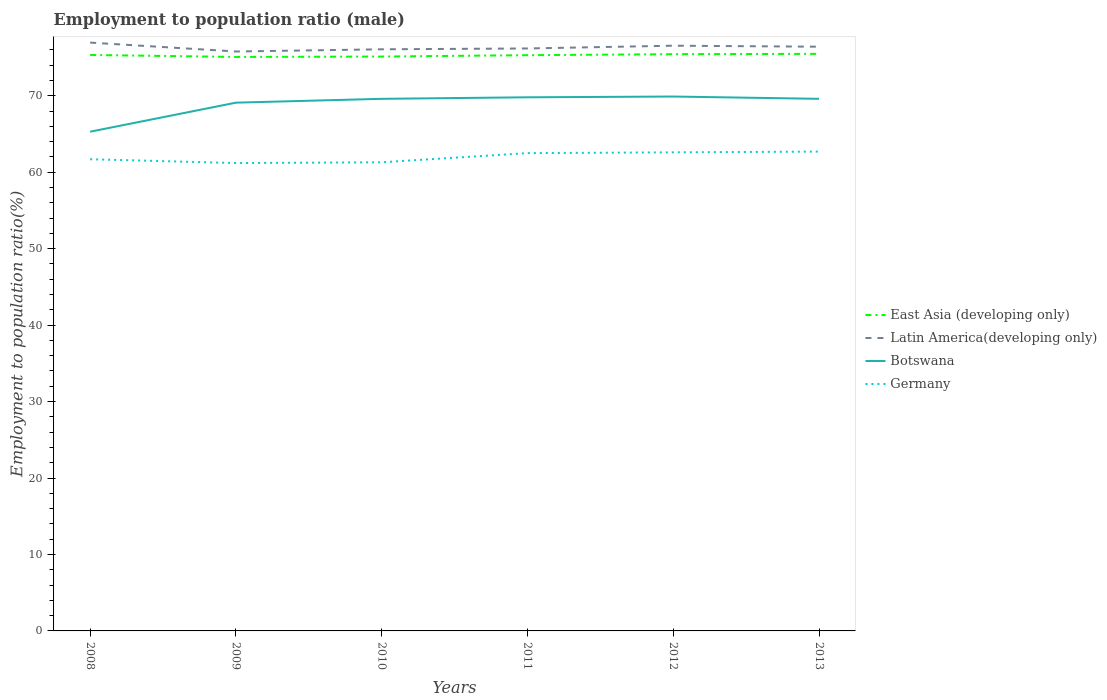How many different coloured lines are there?
Ensure brevity in your answer.  4. Is the number of lines equal to the number of legend labels?
Your answer should be very brief. Yes. Across all years, what is the maximum employment to population ratio in Germany?
Ensure brevity in your answer.  61.2. What is the total employment to population ratio in Botswana in the graph?
Ensure brevity in your answer.  0. What is the difference between the highest and the second highest employment to population ratio in Botswana?
Your answer should be compact. 4.6. What is the difference between the highest and the lowest employment to population ratio in East Asia (developing only)?
Your response must be concise. 4. How many years are there in the graph?
Your answer should be compact. 6. What is the difference between two consecutive major ticks on the Y-axis?
Your response must be concise. 10. Does the graph contain any zero values?
Offer a very short reply. No. Does the graph contain grids?
Your response must be concise. No. Where does the legend appear in the graph?
Make the answer very short. Center right. How are the legend labels stacked?
Provide a succinct answer. Vertical. What is the title of the graph?
Keep it short and to the point. Employment to population ratio (male). What is the label or title of the X-axis?
Your answer should be very brief. Years. What is the label or title of the Y-axis?
Ensure brevity in your answer.  Employment to population ratio(%). What is the Employment to population ratio(%) of East Asia (developing only) in 2008?
Give a very brief answer. 75.34. What is the Employment to population ratio(%) of Latin America(developing only) in 2008?
Your answer should be very brief. 76.96. What is the Employment to population ratio(%) in Botswana in 2008?
Give a very brief answer. 65.3. What is the Employment to population ratio(%) in Germany in 2008?
Ensure brevity in your answer.  61.7. What is the Employment to population ratio(%) of East Asia (developing only) in 2009?
Keep it short and to the point. 75.08. What is the Employment to population ratio(%) of Latin America(developing only) in 2009?
Provide a short and direct response. 75.79. What is the Employment to population ratio(%) of Botswana in 2009?
Provide a short and direct response. 69.1. What is the Employment to population ratio(%) in Germany in 2009?
Offer a terse response. 61.2. What is the Employment to population ratio(%) in East Asia (developing only) in 2010?
Your answer should be compact. 75.13. What is the Employment to population ratio(%) of Latin America(developing only) in 2010?
Your response must be concise. 76.08. What is the Employment to population ratio(%) in Botswana in 2010?
Provide a succinct answer. 69.6. What is the Employment to population ratio(%) in Germany in 2010?
Your response must be concise. 61.3. What is the Employment to population ratio(%) of East Asia (developing only) in 2011?
Offer a very short reply. 75.31. What is the Employment to population ratio(%) of Latin America(developing only) in 2011?
Your answer should be very brief. 76.19. What is the Employment to population ratio(%) in Botswana in 2011?
Provide a succinct answer. 69.8. What is the Employment to population ratio(%) in Germany in 2011?
Ensure brevity in your answer.  62.5. What is the Employment to population ratio(%) of East Asia (developing only) in 2012?
Provide a short and direct response. 75.44. What is the Employment to population ratio(%) of Latin America(developing only) in 2012?
Your answer should be very brief. 76.55. What is the Employment to population ratio(%) of Botswana in 2012?
Your answer should be compact. 69.9. What is the Employment to population ratio(%) of Germany in 2012?
Make the answer very short. 62.6. What is the Employment to population ratio(%) in East Asia (developing only) in 2013?
Your answer should be very brief. 75.48. What is the Employment to population ratio(%) in Latin America(developing only) in 2013?
Ensure brevity in your answer.  76.42. What is the Employment to population ratio(%) in Botswana in 2013?
Offer a terse response. 69.6. What is the Employment to population ratio(%) of Germany in 2013?
Make the answer very short. 62.7. Across all years, what is the maximum Employment to population ratio(%) in East Asia (developing only)?
Provide a short and direct response. 75.48. Across all years, what is the maximum Employment to population ratio(%) in Latin America(developing only)?
Provide a succinct answer. 76.96. Across all years, what is the maximum Employment to population ratio(%) of Botswana?
Offer a terse response. 69.9. Across all years, what is the maximum Employment to population ratio(%) of Germany?
Your answer should be compact. 62.7. Across all years, what is the minimum Employment to population ratio(%) in East Asia (developing only)?
Your answer should be compact. 75.08. Across all years, what is the minimum Employment to population ratio(%) in Latin America(developing only)?
Offer a very short reply. 75.79. Across all years, what is the minimum Employment to population ratio(%) in Botswana?
Make the answer very short. 65.3. Across all years, what is the minimum Employment to population ratio(%) in Germany?
Your response must be concise. 61.2. What is the total Employment to population ratio(%) in East Asia (developing only) in the graph?
Ensure brevity in your answer.  451.79. What is the total Employment to population ratio(%) in Latin America(developing only) in the graph?
Offer a very short reply. 457.98. What is the total Employment to population ratio(%) in Botswana in the graph?
Your answer should be very brief. 413.3. What is the total Employment to population ratio(%) of Germany in the graph?
Make the answer very short. 372. What is the difference between the Employment to population ratio(%) in East Asia (developing only) in 2008 and that in 2009?
Offer a very short reply. 0.26. What is the difference between the Employment to population ratio(%) of Latin America(developing only) in 2008 and that in 2009?
Your answer should be very brief. 1.16. What is the difference between the Employment to population ratio(%) of Germany in 2008 and that in 2009?
Ensure brevity in your answer.  0.5. What is the difference between the Employment to population ratio(%) in East Asia (developing only) in 2008 and that in 2010?
Give a very brief answer. 0.21. What is the difference between the Employment to population ratio(%) of Latin America(developing only) in 2008 and that in 2010?
Offer a terse response. 0.88. What is the difference between the Employment to population ratio(%) in Botswana in 2008 and that in 2010?
Keep it short and to the point. -4.3. What is the difference between the Employment to population ratio(%) of Germany in 2008 and that in 2010?
Your answer should be very brief. 0.4. What is the difference between the Employment to population ratio(%) in East Asia (developing only) in 2008 and that in 2011?
Give a very brief answer. 0.03. What is the difference between the Employment to population ratio(%) in Latin America(developing only) in 2008 and that in 2011?
Offer a terse response. 0.77. What is the difference between the Employment to population ratio(%) of Germany in 2008 and that in 2011?
Your response must be concise. -0.8. What is the difference between the Employment to population ratio(%) in East Asia (developing only) in 2008 and that in 2012?
Your response must be concise. -0.1. What is the difference between the Employment to population ratio(%) in Latin America(developing only) in 2008 and that in 2012?
Give a very brief answer. 0.41. What is the difference between the Employment to population ratio(%) of Botswana in 2008 and that in 2012?
Offer a terse response. -4.6. What is the difference between the Employment to population ratio(%) in Germany in 2008 and that in 2012?
Your response must be concise. -0.9. What is the difference between the Employment to population ratio(%) of East Asia (developing only) in 2008 and that in 2013?
Offer a very short reply. -0.14. What is the difference between the Employment to population ratio(%) in Latin America(developing only) in 2008 and that in 2013?
Make the answer very short. 0.54. What is the difference between the Employment to population ratio(%) of Botswana in 2008 and that in 2013?
Ensure brevity in your answer.  -4.3. What is the difference between the Employment to population ratio(%) in East Asia (developing only) in 2009 and that in 2010?
Provide a succinct answer. -0.05. What is the difference between the Employment to population ratio(%) in Latin America(developing only) in 2009 and that in 2010?
Keep it short and to the point. -0.29. What is the difference between the Employment to population ratio(%) in Germany in 2009 and that in 2010?
Keep it short and to the point. -0.1. What is the difference between the Employment to population ratio(%) of East Asia (developing only) in 2009 and that in 2011?
Your answer should be very brief. -0.23. What is the difference between the Employment to population ratio(%) in Latin America(developing only) in 2009 and that in 2011?
Offer a terse response. -0.4. What is the difference between the Employment to population ratio(%) in Germany in 2009 and that in 2011?
Ensure brevity in your answer.  -1.3. What is the difference between the Employment to population ratio(%) of East Asia (developing only) in 2009 and that in 2012?
Make the answer very short. -0.36. What is the difference between the Employment to population ratio(%) in Latin America(developing only) in 2009 and that in 2012?
Make the answer very short. -0.76. What is the difference between the Employment to population ratio(%) of Botswana in 2009 and that in 2012?
Give a very brief answer. -0.8. What is the difference between the Employment to population ratio(%) of East Asia (developing only) in 2009 and that in 2013?
Your response must be concise. -0.41. What is the difference between the Employment to population ratio(%) in Latin America(developing only) in 2009 and that in 2013?
Keep it short and to the point. -0.63. What is the difference between the Employment to population ratio(%) of Botswana in 2009 and that in 2013?
Provide a succinct answer. -0.5. What is the difference between the Employment to population ratio(%) in East Asia (developing only) in 2010 and that in 2011?
Offer a very short reply. -0.18. What is the difference between the Employment to population ratio(%) of Latin America(developing only) in 2010 and that in 2011?
Offer a terse response. -0.11. What is the difference between the Employment to population ratio(%) of Botswana in 2010 and that in 2011?
Give a very brief answer. -0.2. What is the difference between the Employment to population ratio(%) in East Asia (developing only) in 2010 and that in 2012?
Ensure brevity in your answer.  -0.31. What is the difference between the Employment to population ratio(%) in Latin America(developing only) in 2010 and that in 2012?
Offer a terse response. -0.47. What is the difference between the Employment to population ratio(%) in Botswana in 2010 and that in 2012?
Your answer should be very brief. -0.3. What is the difference between the Employment to population ratio(%) in East Asia (developing only) in 2010 and that in 2013?
Offer a terse response. -0.35. What is the difference between the Employment to population ratio(%) in Latin America(developing only) in 2010 and that in 2013?
Provide a short and direct response. -0.34. What is the difference between the Employment to population ratio(%) in Botswana in 2010 and that in 2013?
Your answer should be compact. 0. What is the difference between the Employment to population ratio(%) in Germany in 2010 and that in 2013?
Ensure brevity in your answer.  -1.4. What is the difference between the Employment to population ratio(%) in East Asia (developing only) in 2011 and that in 2012?
Your answer should be compact. -0.13. What is the difference between the Employment to population ratio(%) of Latin America(developing only) in 2011 and that in 2012?
Offer a very short reply. -0.36. What is the difference between the Employment to population ratio(%) in East Asia (developing only) in 2011 and that in 2013?
Keep it short and to the point. -0.17. What is the difference between the Employment to population ratio(%) in Latin America(developing only) in 2011 and that in 2013?
Give a very brief answer. -0.23. What is the difference between the Employment to population ratio(%) of Botswana in 2011 and that in 2013?
Your answer should be very brief. 0.2. What is the difference between the Employment to population ratio(%) in Germany in 2011 and that in 2013?
Give a very brief answer. -0.2. What is the difference between the Employment to population ratio(%) of East Asia (developing only) in 2012 and that in 2013?
Your answer should be compact. -0.04. What is the difference between the Employment to population ratio(%) in Latin America(developing only) in 2012 and that in 2013?
Offer a terse response. 0.13. What is the difference between the Employment to population ratio(%) in Botswana in 2012 and that in 2013?
Provide a short and direct response. 0.3. What is the difference between the Employment to population ratio(%) of Germany in 2012 and that in 2013?
Provide a succinct answer. -0.1. What is the difference between the Employment to population ratio(%) of East Asia (developing only) in 2008 and the Employment to population ratio(%) of Latin America(developing only) in 2009?
Make the answer very short. -0.45. What is the difference between the Employment to population ratio(%) of East Asia (developing only) in 2008 and the Employment to population ratio(%) of Botswana in 2009?
Make the answer very short. 6.24. What is the difference between the Employment to population ratio(%) of East Asia (developing only) in 2008 and the Employment to population ratio(%) of Germany in 2009?
Your response must be concise. 14.14. What is the difference between the Employment to population ratio(%) in Latin America(developing only) in 2008 and the Employment to population ratio(%) in Botswana in 2009?
Provide a short and direct response. 7.86. What is the difference between the Employment to population ratio(%) in Latin America(developing only) in 2008 and the Employment to population ratio(%) in Germany in 2009?
Make the answer very short. 15.76. What is the difference between the Employment to population ratio(%) of Botswana in 2008 and the Employment to population ratio(%) of Germany in 2009?
Your answer should be very brief. 4.1. What is the difference between the Employment to population ratio(%) of East Asia (developing only) in 2008 and the Employment to population ratio(%) of Latin America(developing only) in 2010?
Provide a succinct answer. -0.74. What is the difference between the Employment to population ratio(%) of East Asia (developing only) in 2008 and the Employment to population ratio(%) of Botswana in 2010?
Your answer should be compact. 5.74. What is the difference between the Employment to population ratio(%) of East Asia (developing only) in 2008 and the Employment to population ratio(%) of Germany in 2010?
Your response must be concise. 14.04. What is the difference between the Employment to population ratio(%) of Latin America(developing only) in 2008 and the Employment to population ratio(%) of Botswana in 2010?
Your answer should be compact. 7.36. What is the difference between the Employment to population ratio(%) in Latin America(developing only) in 2008 and the Employment to population ratio(%) in Germany in 2010?
Provide a succinct answer. 15.66. What is the difference between the Employment to population ratio(%) in East Asia (developing only) in 2008 and the Employment to population ratio(%) in Latin America(developing only) in 2011?
Offer a very short reply. -0.85. What is the difference between the Employment to population ratio(%) of East Asia (developing only) in 2008 and the Employment to population ratio(%) of Botswana in 2011?
Make the answer very short. 5.54. What is the difference between the Employment to population ratio(%) of East Asia (developing only) in 2008 and the Employment to population ratio(%) of Germany in 2011?
Offer a very short reply. 12.84. What is the difference between the Employment to population ratio(%) in Latin America(developing only) in 2008 and the Employment to population ratio(%) in Botswana in 2011?
Your answer should be very brief. 7.16. What is the difference between the Employment to population ratio(%) in Latin America(developing only) in 2008 and the Employment to population ratio(%) in Germany in 2011?
Your response must be concise. 14.46. What is the difference between the Employment to population ratio(%) of Botswana in 2008 and the Employment to population ratio(%) of Germany in 2011?
Provide a succinct answer. 2.8. What is the difference between the Employment to population ratio(%) in East Asia (developing only) in 2008 and the Employment to population ratio(%) in Latin America(developing only) in 2012?
Keep it short and to the point. -1.21. What is the difference between the Employment to population ratio(%) in East Asia (developing only) in 2008 and the Employment to population ratio(%) in Botswana in 2012?
Provide a short and direct response. 5.44. What is the difference between the Employment to population ratio(%) of East Asia (developing only) in 2008 and the Employment to population ratio(%) of Germany in 2012?
Your response must be concise. 12.74. What is the difference between the Employment to population ratio(%) in Latin America(developing only) in 2008 and the Employment to population ratio(%) in Botswana in 2012?
Offer a terse response. 7.06. What is the difference between the Employment to population ratio(%) in Latin America(developing only) in 2008 and the Employment to population ratio(%) in Germany in 2012?
Provide a short and direct response. 14.36. What is the difference between the Employment to population ratio(%) of Botswana in 2008 and the Employment to population ratio(%) of Germany in 2012?
Your answer should be very brief. 2.7. What is the difference between the Employment to population ratio(%) of East Asia (developing only) in 2008 and the Employment to population ratio(%) of Latin America(developing only) in 2013?
Keep it short and to the point. -1.08. What is the difference between the Employment to population ratio(%) of East Asia (developing only) in 2008 and the Employment to population ratio(%) of Botswana in 2013?
Offer a very short reply. 5.74. What is the difference between the Employment to population ratio(%) of East Asia (developing only) in 2008 and the Employment to population ratio(%) of Germany in 2013?
Your answer should be compact. 12.64. What is the difference between the Employment to population ratio(%) in Latin America(developing only) in 2008 and the Employment to population ratio(%) in Botswana in 2013?
Offer a very short reply. 7.36. What is the difference between the Employment to population ratio(%) in Latin America(developing only) in 2008 and the Employment to population ratio(%) in Germany in 2013?
Your answer should be very brief. 14.26. What is the difference between the Employment to population ratio(%) of Botswana in 2008 and the Employment to population ratio(%) of Germany in 2013?
Provide a succinct answer. 2.6. What is the difference between the Employment to population ratio(%) of East Asia (developing only) in 2009 and the Employment to population ratio(%) of Latin America(developing only) in 2010?
Ensure brevity in your answer.  -1. What is the difference between the Employment to population ratio(%) in East Asia (developing only) in 2009 and the Employment to population ratio(%) in Botswana in 2010?
Keep it short and to the point. 5.48. What is the difference between the Employment to population ratio(%) in East Asia (developing only) in 2009 and the Employment to population ratio(%) in Germany in 2010?
Your answer should be very brief. 13.78. What is the difference between the Employment to population ratio(%) of Latin America(developing only) in 2009 and the Employment to population ratio(%) of Botswana in 2010?
Keep it short and to the point. 6.19. What is the difference between the Employment to population ratio(%) in Latin America(developing only) in 2009 and the Employment to population ratio(%) in Germany in 2010?
Provide a short and direct response. 14.49. What is the difference between the Employment to population ratio(%) of East Asia (developing only) in 2009 and the Employment to population ratio(%) of Latin America(developing only) in 2011?
Ensure brevity in your answer.  -1.11. What is the difference between the Employment to population ratio(%) in East Asia (developing only) in 2009 and the Employment to population ratio(%) in Botswana in 2011?
Provide a short and direct response. 5.28. What is the difference between the Employment to population ratio(%) of East Asia (developing only) in 2009 and the Employment to population ratio(%) of Germany in 2011?
Your answer should be very brief. 12.58. What is the difference between the Employment to population ratio(%) of Latin America(developing only) in 2009 and the Employment to population ratio(%) of Botswana in 2011?
Make the answer very short. 5.99. What is the difference between the Employment to population ratio(%) of Latin America(developing only) in 2009 and the Employment to population ratio(%) of Germany in 2011?
Offer a very short reply. 13.29. What is the difference between the Employment to population ratio(%) of Botswana in 2009 and the Employment to population ratio(%) of Germany in 2011?
Ensure brevity in your answer.  6.6. What is the difference between the Employment to population ratio(%) in East Asia (developing only) in 2009 and the Employment to population ratio(%) in Latin America(developing only) in 2012?
Provide a succinct answer. -1.47. What is the difference between the Employment to population ratio(%) in East Asia (developing only) in 2009 and the Employment to population ratio(%) in Botswana in 2012?
Offer a terse response. 5.18. What is the difference between the Employment to population ratio(%) of East Asia (developing only) in 2009 and the Employment to population ratio(%) of Germany in 2012?
Keep it short and to the point. 12.48. What is the difference between the Employment to population ratio(%) of Latin America(developing only) in 2009 and the Employment to population ratio(%) of Botswana in 2012?
Make the answer very short. 5.89. What is the difference between the Employment to population ratio(%) of Latin America(developing only) in 2009 and the Employment to population ratio(%) of Germany in 2012?
Make the answer very short. 13.19. What is the difference between the Employment to population ratio(%) of East Asia (developing only) in 2009 and the Employment to population ratio(%) of Latin America(developing only) in 2013?
Provide a short and direct response. -1.34. What is the difference between the Employment to population ratio(%) of East Asia (developing only) in 2009 and the Employment to population ratio(%) of Botswana in 2013?
Ensure brevity in your answer.  5.48. What is the difference between the Employment to population ratio(%) of East Asia (developing only) in 2009 and the Employment to population ratio(%) of Germany in 2013?
Offer a very short reply. 12.38. What is the difference between the Employment to population ratio(%) of Latin America(developing only) in 2009 and the Employment to population ratio(%) of Botswana in 2013?
Offer a very short reply. 6.19. What is the difference between the Employment to population ratio(%) in Latin America(developing only) in 2009 and the Employment to population ratio(%) in Germany in 2013?
Your answer should be very brief. 13.09. What is the difference between the Employment to population ratio(%) in East Asia (developing only) in 2010 and the Employment to population ratio(%) in Latin America(developing only) in 2011?
Ensure brevity in your answer.  -1.06. What is the difference between the Employment to population ratio(%) in East Asia (developing only) in 2010 and the Employment to population ratio(%) in Botswana in 2011?
Your answer should be compact. 5.33. What is the difference between the Employment to population ratio(%) of East Asia (developing only) in 2010 and the Employment to population ratio(%) of Germany in 2011?
Give a very brief answer. 12.63. What is the difference between the Employment to population ratio(%) in Latin America(developing only) in 2010 and the Employment to population ratio(%) in Botswana in 2011?
Ensure brevity in your answer.  6.28. What is the difference between the Employment to population ratio(%) in Latin America(developing only) in 2010 and the Employment to population ratio(%) in Germany in 2011?
Offer a very short reply. 13.58. What is the difference between the Employment to population ratio(%) in East Asia (developing only) in 2010 and the Employment to population ratio(%) in Latin America(developing only) in 2012?
Offer a very short reply. -1.42. What is the difference between the Employment to population ratio(%) of East Asia (developing only) in 2010 and the Employment to population ratio(%) of Botswana in 2012?
Keep it short and to the point. 5.23. What is the difference between the Employment to population ratio(%) in East Asia (developing only) in 2010 and the Employment to population ratio(%) in Germany in 2012?
Your response must be concise. 12.53. What is the difference between the Employment to population ratio(%) of Latin America(developing only) in 2010 and the Employment to population ratio(%) of Botswana in 2012?
Offer a very short reply. 6.18. What is the difference between the Employment to population ratio(%) of Latin America(developing only) in 2010 and the Employment to population ratio(%) of Germany in 2012?
Offer a very short reply. 13.48. What is the difference between the Employment to population ratio(%) of East Asia (developing only) in 2010 and the Employment to population ratio(%) of Latin America(developing only) in 2013?
Your answer should be very brief. -1.29. What is the difference between the Employment to population ratio(%) in East Asia (developing only) in 2010 and the Employment to population ratio(%) in Botswana in 2013?
Provide a short and direct response. 5.53. What is the difference between the Employment to population ratio(%) of East Asia (developing only) in 2010 and the Employment to population ratio(%) of Germany in 2013?
Provide a short and direct response. 12.43. What is the difference between the Employment to population ratio(%) of Latin America(developing only) in 2010 and the Employment to population ratio(%) of Botswana in 2013?
Provide a short and direct response. 6.48. What is the difference between the Employment to population ratio(%) of Latin America(developing only) in 2010 and the Employment to population ratio(%) of Germany in 2013?
Your response must be concise. 13.38. What is the difference between the Employment to population ratio(%) of Botswana in 2010 and the Employment to population ratio(%) of Germany in 2013?
Offer a very short reply. 6.9. What is the difference between the Employment to population ratio(%) of East Asia (developing only) in 2011 and the Employment to population ratio(%) of Latin America(developing only) in 2012?
Your answer should be compact. -1.24. What is the difference between the Employment to population ratio(%) in East Asia (developing only) in 2011 and the Employment to population ratio(%) in Botswana in 2012?
Keep it short and to the point. 5.41. What is the difference between the Employment to population ratio(%) of East Asia (developing only) in 2011 and the Employment to population ratio(%) of Germany in 2012?
Offer a very short reply. 12.71. What is the difference between the Employment to population ratio(%) of Latin America(developing only) in 2011 and the Employment to population ratio(%) of Botswana in 2012?
Keep it short and to the point. 6.29. What is the difference between the Employment to population ratio(%) in Latin America(developing only) in 2011 and the Employment to population ratio(%) in Germany in 2012?
Provide a succinct answer. 13.59. What is the difference between the Employment to population ratio(%) in Botswana in 2011 and the Employment to population ratio(%) in Germany in 2012?
Offer a terse response. 7.2. What is the difference between the Employment to population ratio(%) of East Asia (developing only) in 2011 and the Employment to population ratio(%) of Latin America(developing only) in 2013?
Provide a short and direct response. -1.11. What is the difference between the Employment to population ratio(%) in East Asia (developing only) in 2011 and the Employment to population ratio(%) in Botswana in 2013?
Offer a very short reply. 5.71. What is the difference between the Employment to population ratio(%) in East Asia (developing only) in 2011 and the Employment to population ratio(%) in Germany in 2013?
Make the answer very short. 12.61. What is the difference between the Employment to population ratio(%) in Latin America(developing only) in 2011 and the Employment to population ratio(%) in Botswana in 2013?
Ensure brevity in your answer.  6.59. What is the difference between the Employment to population ratio(%) in Latin America(developing only) in 2011 and the Employment to population ratio(%) in Germany in 2013?
Keep it short and to the point. 13.49. What is the difference between the Employment to population ratio(%) of Botswana in 2011 and the Employment to population ratio(%) of Germany in 2013?
Your answer should be compact. 7.1. What is the difference between the Employment to population ratio(%) in East Asia (developing only) in 2012 and the Employment to population ratio(%) in Latin America(developing only) in 2013?
Make the answer very short. -0.98. What is the difference between the Employment to population ratio(%) in East Asia (developing only) in 2012 and the Employment to population ratio(%) in Botswana in 2013?
Offer a terse response. 5.84. What is the difference between the Employment to population ratio(%) of East Asia (developing only) in 2012 and the Employment to population ratio(%) of Germany in 2013?
Your answer should be compact. 12.74. What is the difference between the Employment to population ratio(%) in Latin America(developing only) in 2012 and the Employment to population ratio(%) in Botswana in 2013?
Offer a terse response. 6.95. What is the difference between the Employment to population ratio(%) in Latin America(developing only) in 2012 and the Employment to population ratio(%) in Germany in 2013?
Ensure brevity in your answer.  13.85. What is the average Employment to population ratio(%) of East Asia (developing only) per year?
Provide a succinct answer. 75.3. What is the average Employment to population ratio(%) of Latin America(developing only) per year?
Your response must be concise. 76.33. What is the average Employment to population ratio(%) of Botswana per year?
Offer a very short reply. 68.88. What is the average Employment to population ratio(%) in Germany per year?
Offer a terse response. 62. In the year 2008, what is the difference between the Employment to population ratio(%) of East Asia (developing only) and Employment to population ratio(%) of Latin America(developing only)?
Offer a very short reply. -1.62. In the year 2008, what is the difference between the Employment to population ratio(%) of East Asia (developing only) and Employment to population ratio(%) of Botswana?
Give a very brief answer. 10.04. In the year 2008, what is the difference between the Employment to population ratio(%) of East Asia (developing only) and Employment to population ratio(%) of Germany?
Offer a terse response. 13.64. In the year 2008, what is the difference between the Employment to population ratio(%) of Latin America(developing only) and Employment to population ratio(%) of Botswana?
Provide a short and direct response. 11.66. In the year 2008, what is the difference between the Employment to population ratio(%) of Latin America(developing only) and Employment to population ratio(%) of Germany?
Your response must be concise. 15.26. In the year 2009, what is the difference between the Employment to population ratio(%) of East Asia (developing only) and Employment to population ratio(%) of Latin America(developing only)?
Give a very brief answer. -0.71. In the year 2009, what is the difference between the Employment to population ratio(%) in East Asia (developing only) and Employment to population ratio(%) in Botswana?
Your response must be concise. 5.98. In the year 2009, what is the difference between the Employment to population ratio(%) in East Asia (developing only) and Employment to population ratio(%) in Germany?
Give a very brief answer. 13.88. In the year 2009, what is the difference between the Employment to population ratio(%) of Latin America(developing only) and Employment to population ratio(%) of Botswana?
Give a very brief answer. 6.69. In the year 2009, what is the difference between the Employment to population ratio(%) in Latin America(developing only) and Employment to population ratio(%) in Germany?
Make the answer very short. 14.59. In the year 2010, what is the difference between the Employment to population ratio(%) of East Asia (developing only) and Employment to population ratio(%) of Latin America(developing only)?
Provide a short and direct response. -0.95. In the year 2010, what is the difference between the Employment to population ratio(%) of East Asia (developing only) and Employment to population ratio(%) of Botswana?
Make the answer very short. 5.53. In the year 2010, what is the difference between the Employment to population ratio(%) in East Asia (developing only) and Employment to population ratio(%) in Germany?
Offer a terse response. 13.83. In the year 2010, what is the difference between the Employment to population ratio(%) in Latin America(developing only) and Employment to population ratio(%) in Botswana?
Keep it short and to the point. 6.48. In the year 2010, what is the difference between the Employment to population ratio(%) of Latin America(developing only) and Employment to population ratio(%) of Germany?
Provide a succinct answer. 14.78. In the year 2011, what is the difference between the Employment to population ratio(%) in East Asia (developing only) and Employment to population ratio(%) in Latin America(developing only)?
Provide a succinct answer. -0.88. In the year 2011, what is the difference between the Employment to population ratio(%) in East Asia (developing only) and Employment to population ratio(%) in Botswana?
Your answer should be very brief. 5.51. In the year 2011, what is the difference between the Employment to population ratio(%) of East Asia (developing only) and Employment to population ratio(%) of Germany?
Ensure brevity in your answer.  12.81. In the year 2011, what is the difference between the Employment to population ratio(%) in Latin America(developing only) and Employment to population ratio(%) in Botswana?
Make the answer very short. 6.39. In the year 2011, what is the difference between the Employment to population ratio(%) of Latin America(developing only) and Employment to population ratio(%) of Germany?
Give a very brief answer. 13.69. In the year 2012, what is the difference between the Employment to population ratio(%) of East Asia (developing only) and Employment to population ratio(%) of Latin America(developing only)?
Offer a terse response. -1.11. In the year 2012, what is the difference between the Employment to population ratio(%) in East Asia (developing only) and Employment to population ratio(%) in Botswana?
Ensure brevity in your answer.  5.54. In the year 2012, what is the difference between the Employment to population ratio(%) in East Asia (developing only) and Employment to population ratio(%) in Germany?
Give a very brief answer. 12.84. In the year 2012, what is the difference between the Employment to population ratio(%) in Latin America(developing only) and Employment to population ratio(%) in Botswana?
Make the answer very short. 6.65. In the year 2012, what is the difference between the Employment to population ratio(%) in Latin America(developing only) and Employment to population ratio(%) in Germany?
Give a very brief answer. 13.95. In the year 2012, what is the difference between the Employment to population ratio(%) of Botswana and Employment to population ratio(%) of Germany?
Offer a very short reply. 7.3. In the year 2013, what is the difference between the Employment to population ratio(%) in East Asia (developing only) and Employment to population ratio(%) in Latin America(developing only)?
Your answer should be very brief. -0.93. In the year 2013, what is the difference between the Employment to population ratio(%) of East Asia (developing only) and Employment to population ratio(%) of Botswana?
Provide a short and direct response. 5.88. In the year 2013, what is the difference between the Employment to population ratio(%) of East Asia (developing only) and Employment to population ratio(%) of Germany?
Your response must be concise. 12.78. In the year 2013, what is the difference between the Employment to population ratio(%) of Latin America(developing only) and Employment to population ratio(%) of Botswana?
Your answer should be compact. 6.82. In the year 2013, what is the difference between the Employment to population ratio(%) of Latin America(developing only) and Employment to population ratio(%) of Germany?
Keep it short and to the point. 13.72. In the year 2013, what is the difference between the Employment to population ratio(%) of Botswana and Employment to population ratio(%) of Germany?
Offer a very short reply. 6.9. What is the ratio of the Employment to population ratio(%) in East Asia (developing only) in 2008 to that in 2009?
Give a very brief answer. 1. What is the ratio of the Employment to population ratio(%) in Latin America(developing only) in 2008 to that in 2009?
Provide a short and direct response. 1.02. What is the ratio of the Employment to population ratio(%) in Botswana in 2008 to that in 2009?
Provide a succinct answer. 0.94. What is the ratio of the Employment to population ratio(%) in Germany in 2008 to that in 2009?
Offer a very short reply. 1.01. What is the ratio of the Employment to population ratio(%) of East Asia (developing only) in 2008 to that in 2010?
Your response must be concise. 1. What is the ratio of the Employment to population ratio(%) of Latin America(developing only) in 2008 to that in 2010?
Your response must be concise. 1.01. What is the ratio of the Employment to population ratio(%) of Botswana in 2008 to that in 2010?
Make the answer very short. 0.94. What is the ratio of the Employment to population ratio(%) of East Asia (developing only) in 2008 to that in 2011?
Give a very brief answer. 1. What is the ratio of the Employment to population ratio(%) of Botswana in 2008 to that in 2011?
Make the answer very short. 0.94. What is the ratio of the Employment to population ratio(%) in Germany in 2008 to that in 2011?
Offer a very short reply. 0.99. What is the ratio of the Employment to population ratio(%) of East Asia (developing only) in 2008 to that in 2012?
Your response must be concise. 1. What is the ratio of the Employment to population ratio(%) of Botswana in 2008 to that in 2012?
Keep it short and to the point. 0.93. What is the ratio of the Employment to population ratio(%) of Germany in 2008 to that in 2012?
Provide a short and direct response. 0.99. What is the ratio of the Employment to population ratio(%) of Latin America(developing only) in 2008 to that in 2013?
Offer a terse response. 1.01. What is the ratio of the Employment to population ratio(%) in Botswana in 2008 to that in 2013?
Ensure brevity in your answer.  0.94. What is the ratio of the Employment to population ratio(%) in Germany in 2008 to that in 2013?
Your answer should be compact. 0.98. What is the ratio of the Employment to population ratio(%) of Botswana in 2009 to that in 2010?
Make the answer very short. 0.99. What is the ratio of the Employment to population ratio(%) in East Asia (developing only) in 2009 to that in 2011?
Offer a terse response. 1. What is the ratio of the Employment to population ratio(%) in Botswana in 2009 to that in 2011?
Give a very brief answer. 0.99. What is the ratio of the Employment to population ratio(%) of Germany in 2009 to that in 2011?
Provide a succinct answer. 0.98. What is the ratio of the Employment to population ratio(%) in Latin America(developing only) in 2009 to that in 2012?
Your response must be concise. 0.99. What is the ratio of the Employment to population ratio(%) in Germany in 2009 to that in 2012?
Keep it short and to the point. 0.98. What is the ratio of the Employment to population ratio(%) in Botswana in 2009 to that in 2013?
Offer a terse response. 0.99. What is the ratio of the Employment to population ratio(%) of Germany in 2009 to that in 2013?
Your response must be concise. 0.98. What is the ratio of the Employment to population ratio(%) of Botswana in 2010 to that in 2011?
Offer a very short reply. 1. What is the ratio of the Employment to population ratio(%) of Germany in 2010 to that in 2011?
Provide a short and direct response. 0.98. What is the ratio of the Employment to population ratio(%) of Latin America(developing only) in 2010 to that in 2012?
Your answer should be very brief. 0.99. What is the ratio of the Employment to population ratio(%) of Germany in 2010 to that in 2012?
Make the answer very short. 0.98. What is the ratio of the Employment to population ratio(%) in East Asia (developing only) in 2010 to that in 2013?
Provide a short and direct response. 1. What is the ratio of the Employment to population ratio(%) in Latin America(developing only) in 2010 to that in 2013?
Provide a succinct answer. 1. What is the ratio of the Employment to population ratio(%) in Botswana in 2010 to that in 2013?
Your answer should be compact. 1. What is the ratio of the Employment to population ratio(%) in Germany in 2010 to that in 2013?
Give a very brief answer. 0.98. What is the ratio of the Employment to population ratio(%) of East Asia (developing only) in 2011 to that in 2012?
Give a very brief answer. 1. What is the ratio of the Employment to population ratio(%) in East Asia (developing only) in 2011 to that in 2013?
Your response must be concise. 1. What is the ratio of the Employment to population ratio(%) in Latin America(developing only) in 2011 to that in 2013?
Ensure brevity in your answer.  1. What is the ratio of the Employment to population ratio(%) in Germany in 2011 to that in 2013?
Offer a very short reply. 1. What is the ratio of the Employment to population ratio(%) in East Asia (developing only) in 2012 to that in 2013?
Make the answer very short. 1. What is the ratio of the Employment to population ratio(%) in Latin America(developing only) in 2012 to that in 2013?
Your answer should be very brief. 1. What is the ratio of the Employment to population ratio(%) in Botswana in 2012 to that in 2013?
Offer a very short reply. 1. What is the ratio of the Employment to population ratio(%) in Germany in 2012 to that in 2013?
Your answer should be very brief. 1. What is the difference between the highest and the second highest Employment to population ratio(%) of East Asia (developing only)?
Your answer should be very brief. 0.04. What is the difference between the highest and the second highest Employment to population ratio(%) in Latin America(developing only)?
Provide a short and direct response. 0.41. What is the difference between the highest and the lowest Employment to population ratio(%) in East Asia (developing only)?
Keep it short and to the point. 0.41. What is the difference between the highest and the lowest Employment to population ratio(%) of Latin America(developing only)?
Give a very brief answer. 1.16. What is the difference between the highest and the lowest Employment to population ratio(%) of Botswana?
Provide a short and direct response. 4.6. What is the difference between the highest and the lowest Employment to population ratio(%) of Germany?
Offer a very short reply. 1.5. 